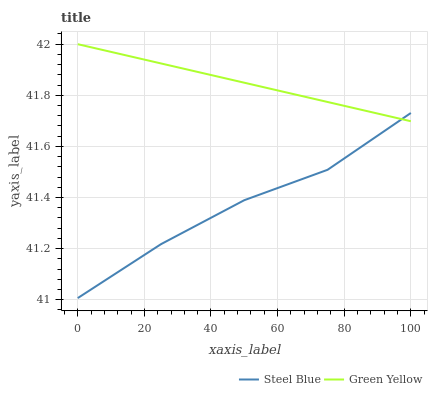Does Steel Blue have the minimum area under the curve?
Answer yes or no. Yes. Does Steel Blue have the maximum area under the curve?
Answer yes or no. No. Is Green Yellow the smoothest?
Answer yes or no. Yes. Is Steel Blue the roughest?
Answer yes or no. Yes. Is Steel Blue the smoothest?
Answer yes or no. No. Does Steel Blue have the highest value?
Answer yes or no. No. 